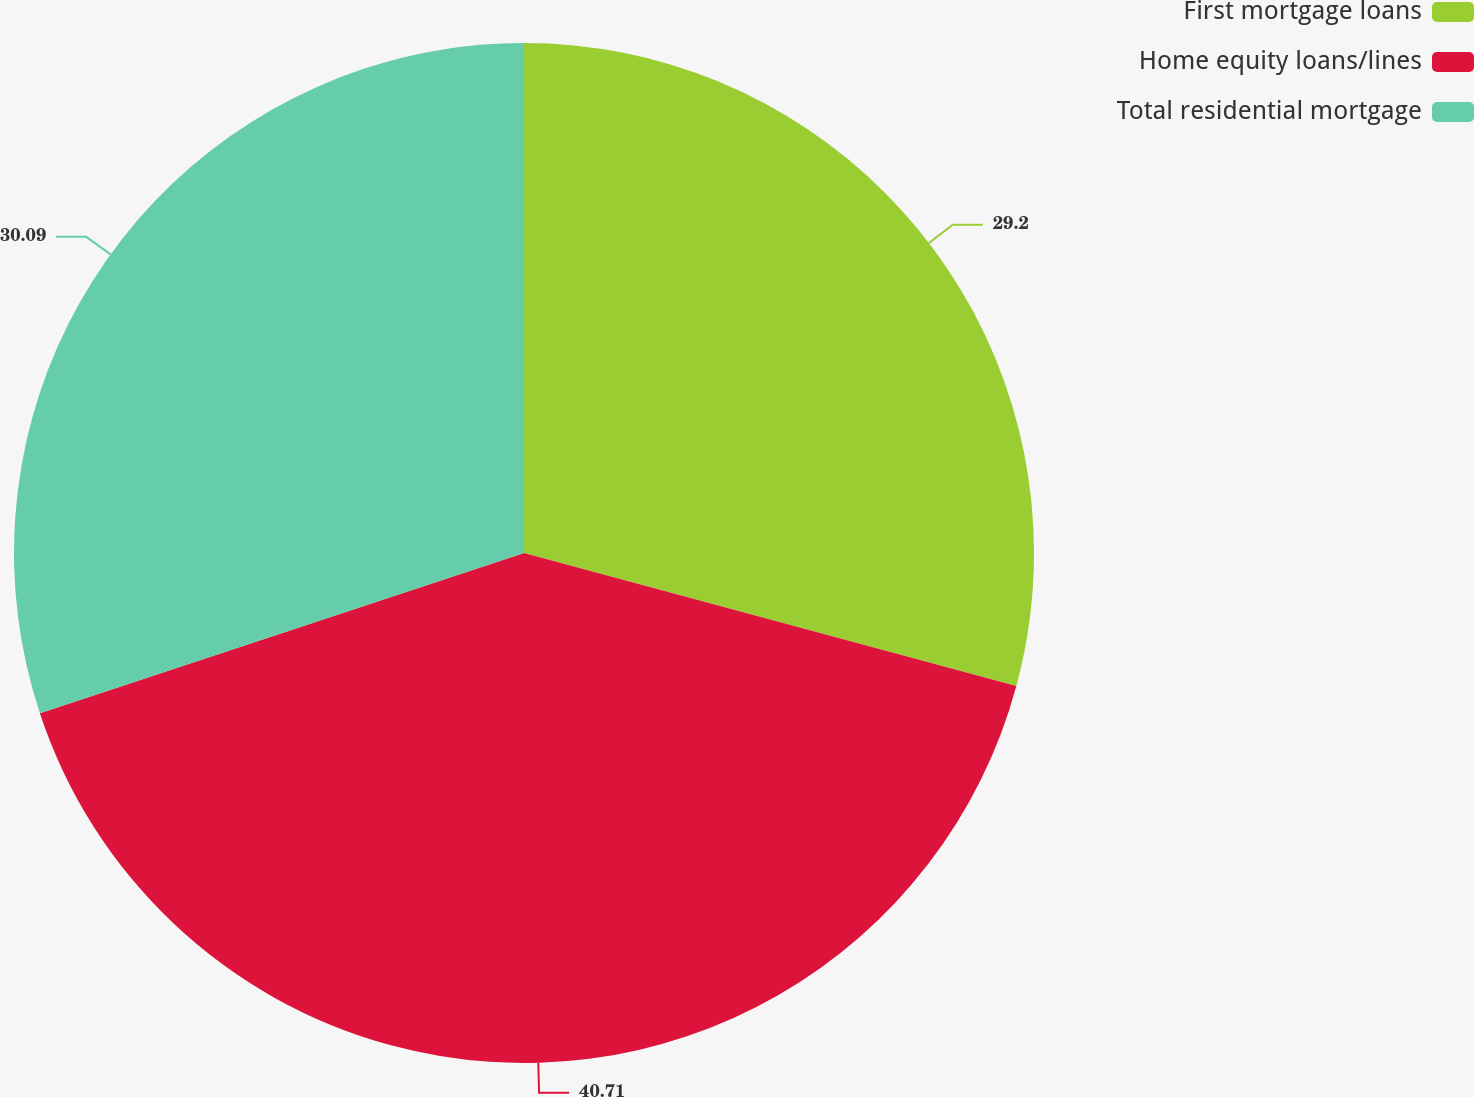<chart> <loc_0><loc_0><loc_500><loc_500><pie_chart><fcel>First mortgage loans<fcel>Home equity loans/lines<fcel>Total residential mortgage<nl><fcel>29.2%<fcel>40.71%<fcel>30.09%<nl></chart> 